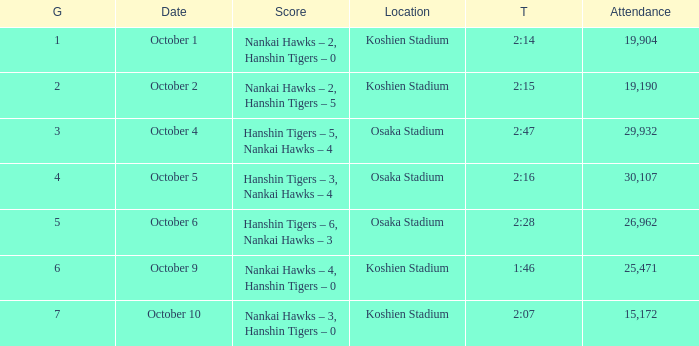How many games had a Time of 2:14? 1.0. 